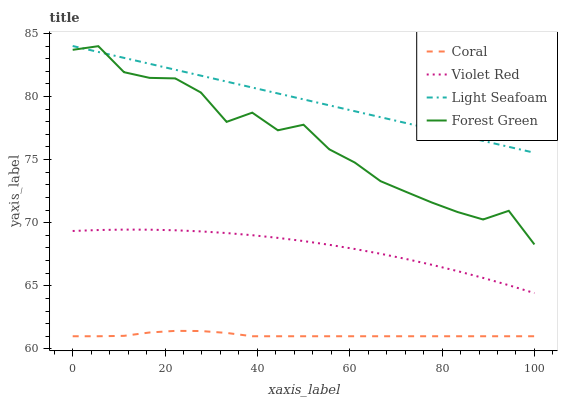Does Coral have the minimum area under the curve?
Answer yes or no. Yes. Does Light Seafoam have the maximum area under the curve?
Answer yes or no. Yes. Does Light Seafoam have the minimum area under the curve?
Answer yes or no. No. Does Coral have the maximum area under the curve?
Answer yes or no. No. Is Light Seafoam the smoothest?
Answer yes or no. Yes. Is Forest Green the roughest?
Answer yes or no. Yes. Is Coral the smoothest?
Answer yes or no. No. Is Coral the roughest?
Answer yes or no. No. Does Coral have the lowest value?
Answer yes or no. Yes. Does Light Seafoam have the lowest value?
Answer yes or no. No. Does Light Seafoam have the highest value?
Answer yes or no. Yes. Does Coral have the highest value?
Answer yes or no. No. Is Coral less than Violet Red?
Answer yes or no. Yes. Is Forest Green greater than Coral?
Answer yes or no. Yes. Does Forest Green intersect Light Seafoam?
Answer yes or no. Yes. Is Forest Green less than Light Seafoam?
Answer yes or no. No. Is Forest Green greater than Light Seafoam?
Answer yes or no. No. Does Coral intersect Violet Red?
Answer yes or no. No. 